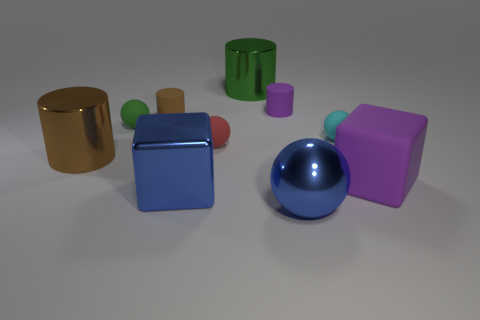Is the color of the big sphere the same as the metallic block?
Provide a succinct answer. Yes. What number of other things are the same shape as the green metallic thing?
Give a very brief answer. 3. Are there more red balls behind the big blue sphere than large green cylinders left of the green cylinder?
Give a very brief answer. Yes. There is a brown thing in front of the brown matte cylinder; is its size the same as the purple rubber thing on the left side of the rubber cube?
Give a very brief answer. No. The green shiny object is what shape?
Make the answer very short. Cylinder. There is a rubber cylinder that is the same color as the matte block; what is its size?
Offer a terse response. Small. What is the color of the big cylinder that is made of the same material as the large brown object?
Keep it short and to the point. Green. Are the blue block and the purple thing behind the big rubber cube made of the same material?
Provide a succinct answer. No. What color is the shiny block?
Make the answer very short. Blue. What is the size of the block that is the same material as the purple cylinder?
Provide a short and direct response. Large. 